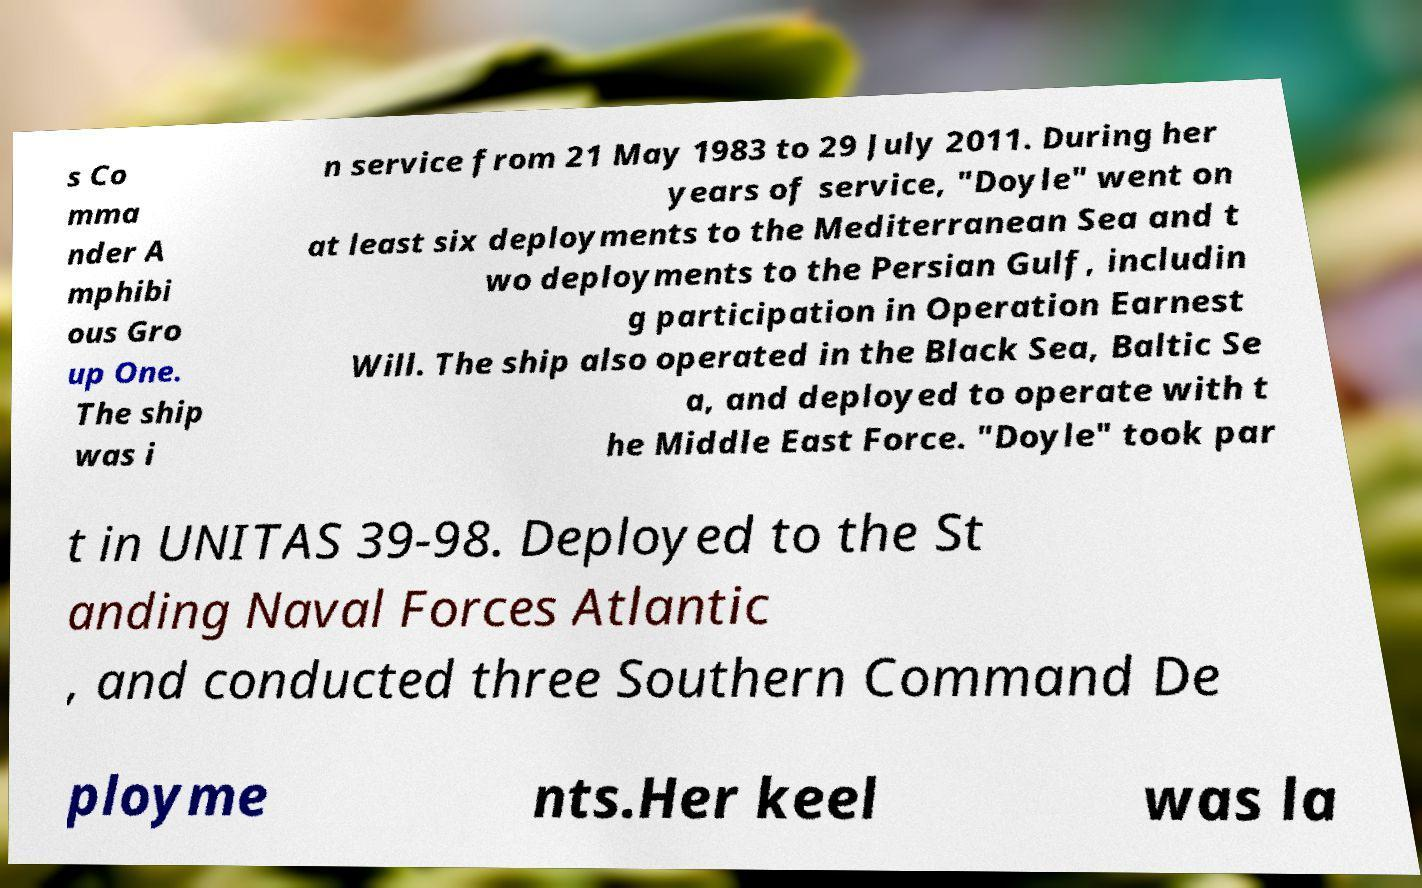Can you accurately transcribe the text from the provided image for me? s Co mma nder A mphibi ous Gro up One. The ship was i n service from 21 May 1983 to 29 July 2011. During her years of service, "Doyle" went on at least six deployments to the Mediterranean Sea and t wo deployments to the Persian Gulf, includin g participation in Operation Earnest Will. The ship also operated in the Black Sea, Baltic Se a, and deployed to operate with t he Middle East Force. "Doyle" took par t in UNITAS 39-98. Deployed to the St anding Naval Forces Atlantic , and conducted three Southern Command De ployme nts.Her keel was la 